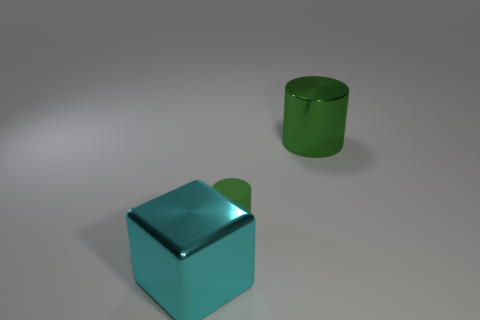Add 3 blue matte things. How many objects exist? 6 Subtract all cylinders. How many objects are left? 1 Subtract 1 blocks. How many blocks are left? 0 Subtract all blue blocks. Subtract all blue cylinders. How many blocks are left? 1 Subtract all metallic cylinders. Subtract all large cyan shiny blocks. How many objects are left? 1 Add 1 big cyan shiny blocks. How many big cyan shiny blocks are left? 2 Add 2 green shiny objects. How many green shiny objects exist? 3 Subtract 0 yellow cylinders. How many objects are left? 3 